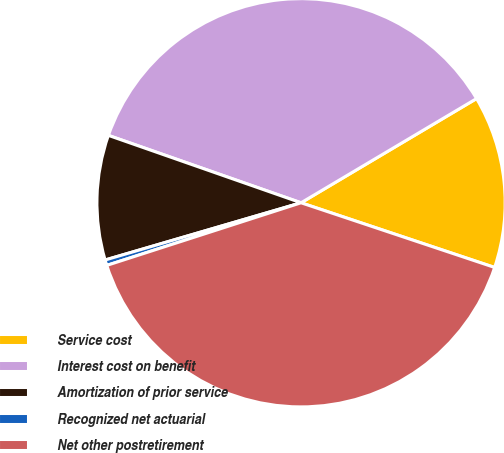Convert chart. <chart><loc_0><loc_0><loc_500><loc_500><pie_chart><fcel>Service cost<fcel>Interest cost on benefit<fcel>Amortization of prior service<fcel>Recognized net actuarial<fcel>Net other postretirement<nl><fcel>13.66%<fcel>36.12%<fcel>9.88%<fcel>0.44%<fcel>39.91%<nl></chart> 